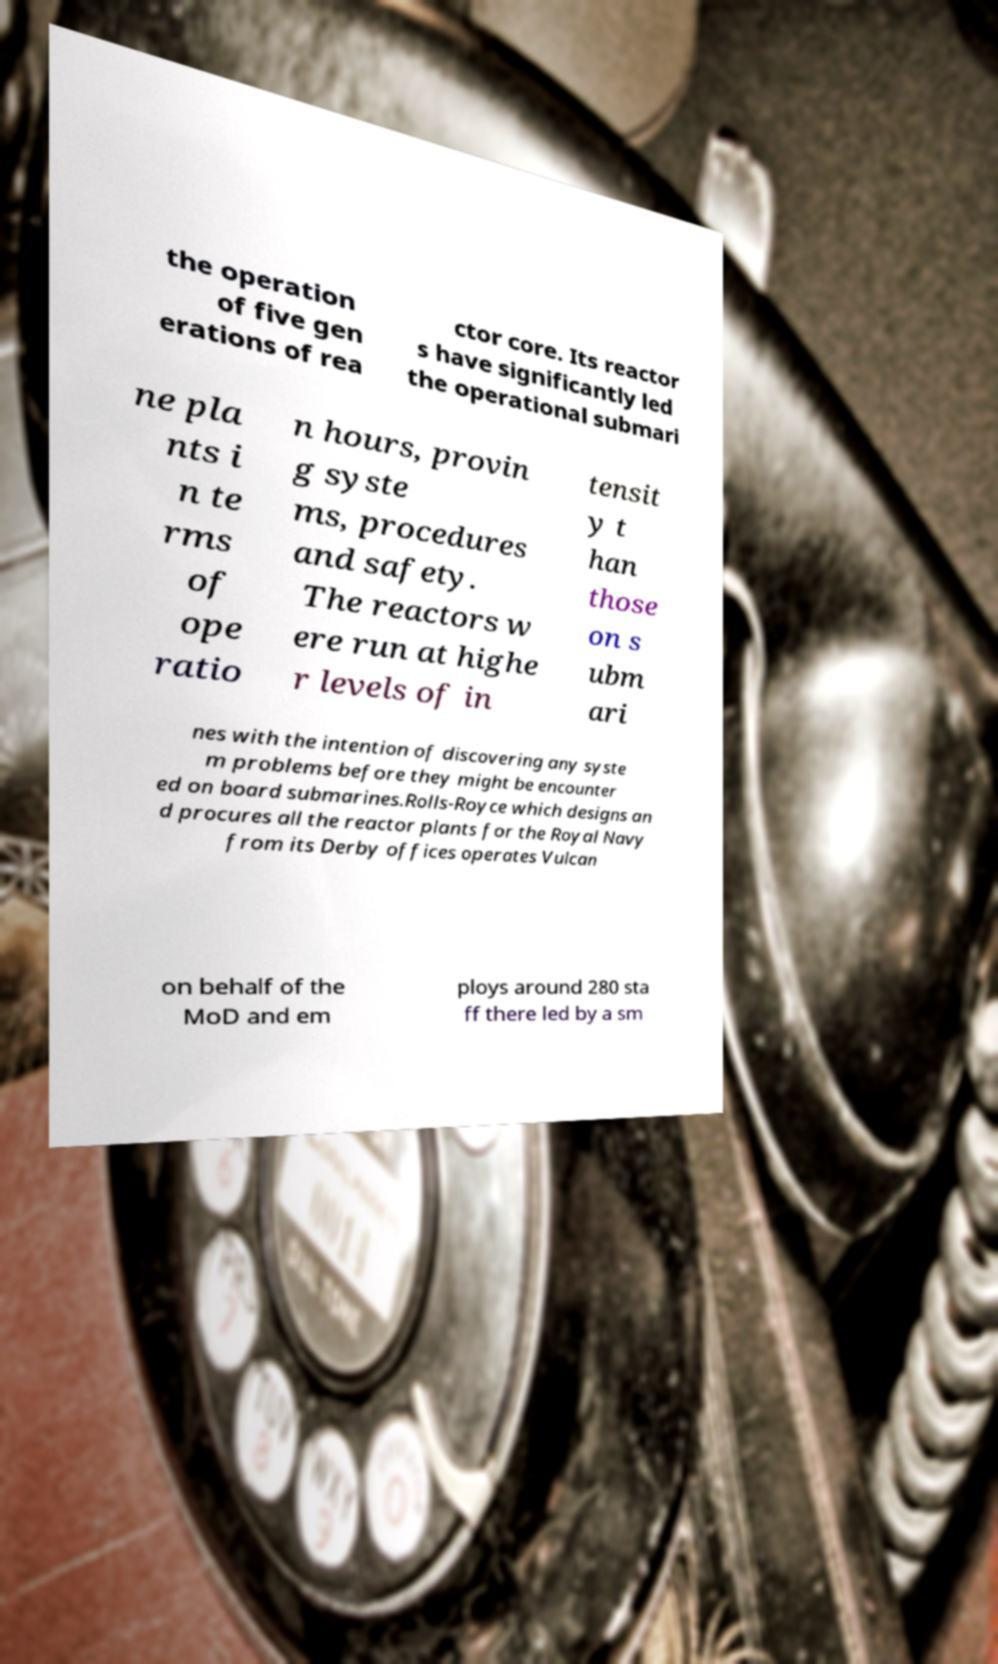There's text embedded in this image that I need extracted. Can you transcribe it verbatim? the operation of five gen erations of rea ctor core. Its reactor s have significantly led the operational submari ne pla nts i n te rms of ope ratio n hours, provin g syste ms, procedures and safety. The reactors w ere run at highe r levels of in tensit y t han those on s ubm ari nes with the intention of discovering any syste m problems before they might be encounter ed on board submarines.Rolls-Royce which designs an d procures all the reactor plants for the Royal Navy from its Derby offices operates Vulcan on behalf of the MoD and em ploys around 280 sta ff there led by a sm 